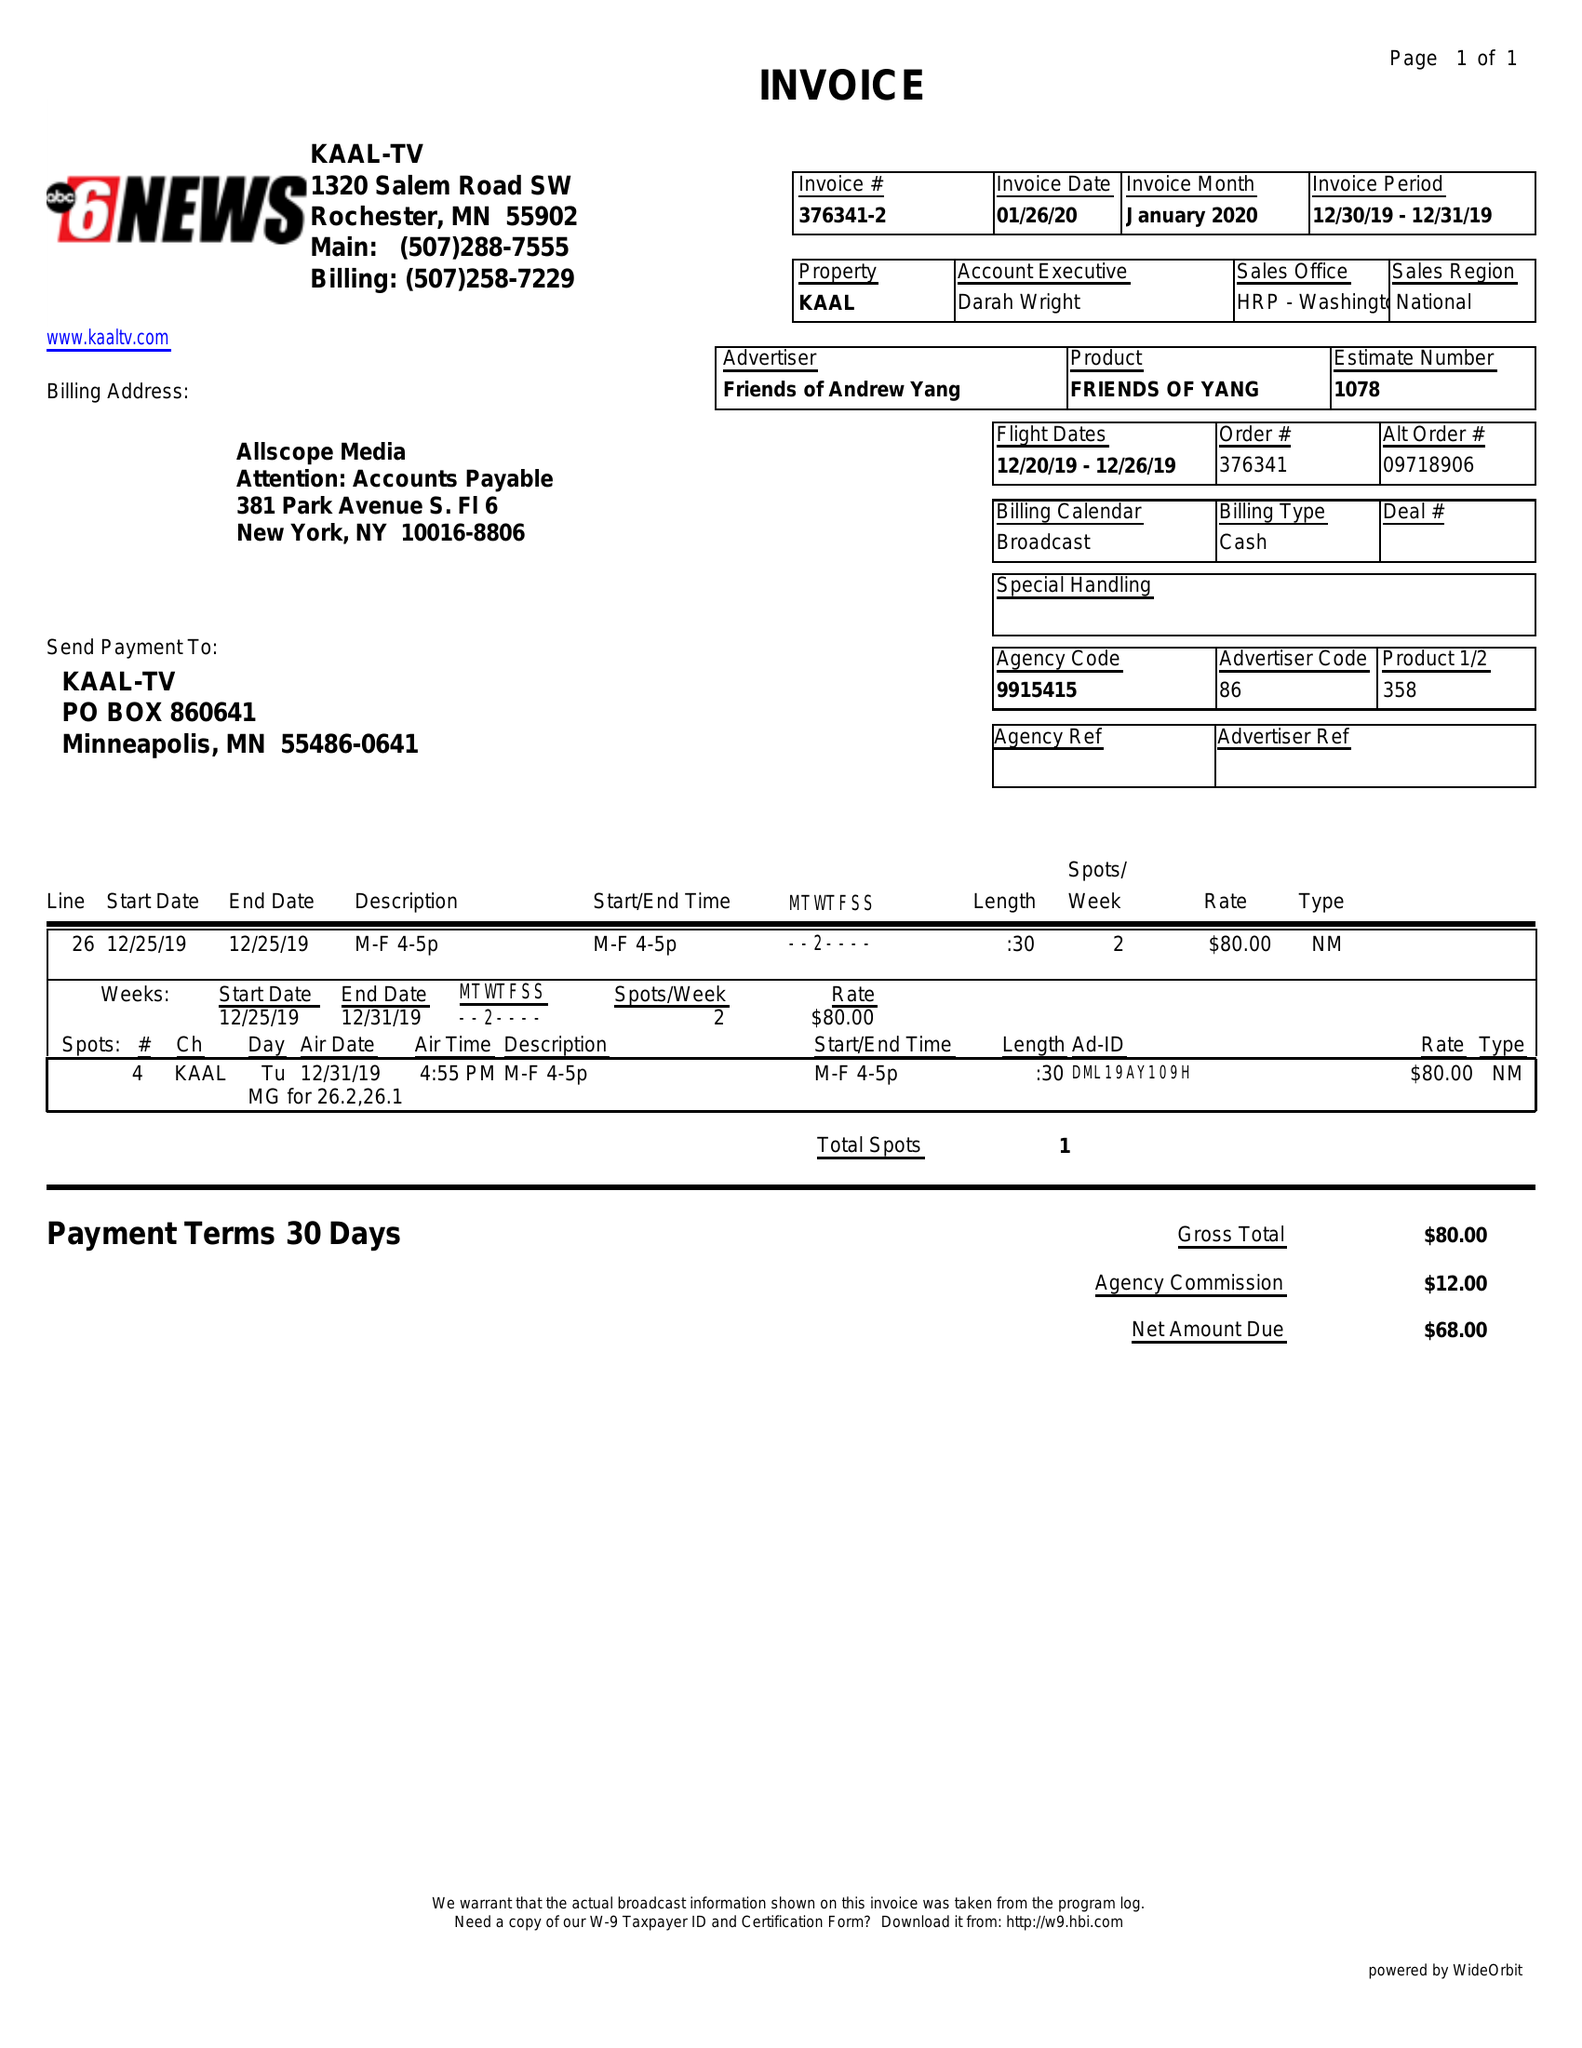What is the value for the flight_from?
Answer the question using a single word or phrase. 12/20/19 